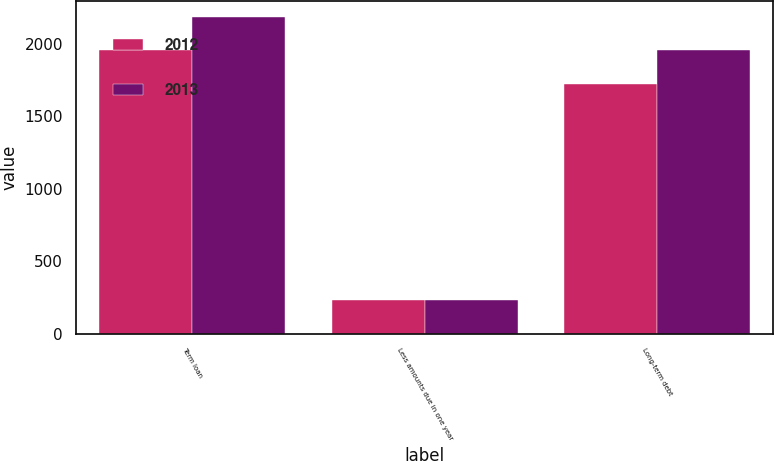Convert chart. <chart><loc_0><loc_0><loc_500><loc_500><stacked_bar_chart><ecel><fcel>Term loan<fcel>Less amounts due in one year<fcel>Long-term debt<nl><fcel>2012<fcel>1955<fcel>230<fcel>1725<nl><fcel>2013<fcel>2185<fcel>230<fcel>1955<nl></chart> 